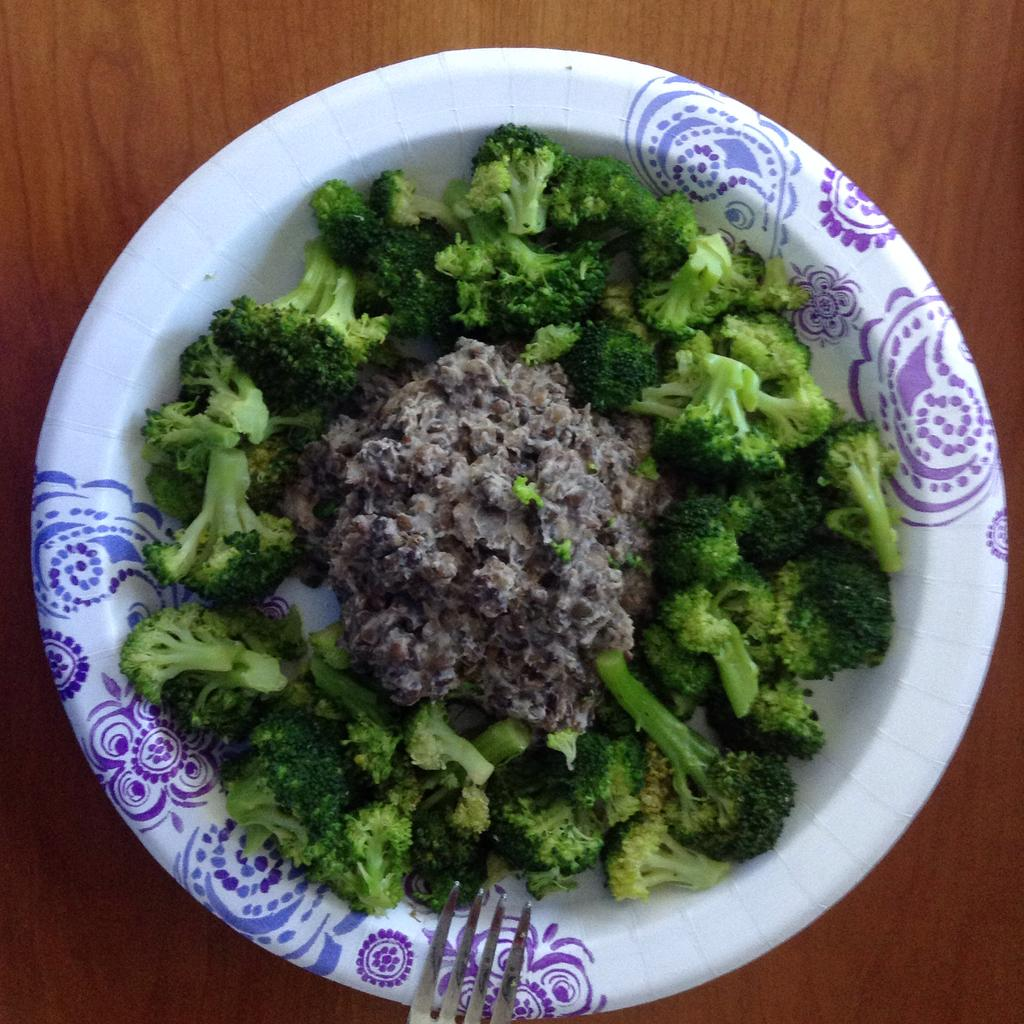What is the main food item in the image? There is a bowl of broccoli in the image. Are there any other food items visible in the image? Yes, there are other food items in the image. What utensil can be seen in the image? There is a fork on a wooden surface in the image. What type of peace symbol can be seen in the image? There is no peace symbol present in the image. Can you describe the donkey that is sitting next to the bowl of broccoli in the image? There is no donkey present in the image. 